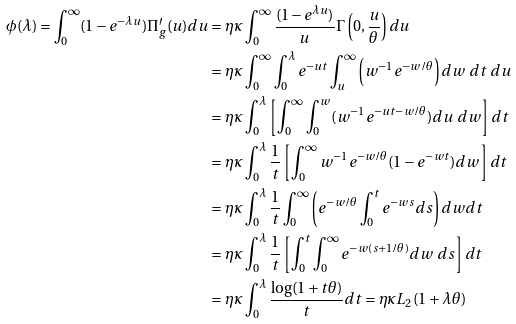Convert formula to latex. <formula><loc_0><loc_0><loc_500><loc_500>\phi ( \lambda ) = \int _ { 0 } ^ { \infty } ( 1 - e ^ { - \lambda u } ) \Pi ^ { \prime } _ { g } ( u ) d u & = \eta \kappa \int _ { 0 } ^ { \infty } \frac { ( 1 - e ^ { \lambda u } ) } { u } \Gamma \left ( 0 , \frac { u } { \theta } \right ) d u \\ & = \eta \kappa \int _ { 0 } ^ { \infty } \int _ { 0 } ^ { \lambda } e ^ { - u t } \int _ { u } ^ { \infty } \left ( w ^ { - 1 } e ^ { - w / \theta } \right ) d w \ d t \ d u \\ & = \eta \kappa \int _ { 0 } ^ { \lambda } \left [ \int _ { 0 } ^ { \infty } \int _ { 0 } ^ { w } ( w ^ { - 1 } e ^ { - u t - w / \theta } ) d u \ d w \right ] d t \\ & = \eta \kappa \int _ { 0 } ^ { \lambda } \frac { 1 } { t } \left [ \int _ { 0 } ^ { \infty } w ^ { - 1 } e ^ { - w / \theta } ( 1 - e ^ { - w t } ) d w \right ] d t \\ & = \eta \kappa \int _ { 0 } ^ { \lambda } \frac { 1 } { t } \int _ { 0 } ^ { \infty } \left ( e ^ { - w / \theta } \int _ { 0 } ^ { t } e ^ { - w s } d s \right ) d w d t \\ & = \eta \kappa \int _ { 0 } ^ { \lambda } \frac { 1 } { t } \left [ \int _ { 0 } ^ { t } \int _ { 0 } ^ { \infty } e ^ { - w ( s + 1 / \theta ) } d w \ d s \right ] d t \\ & = \eta \kappa \int _ { 0 } ^ { \lambda } \frac { \log ( 1 + t \theta ) } { t } d t = \eta \kappa L _ { 2 } ( 1 + \lambda \theta )</formula> 